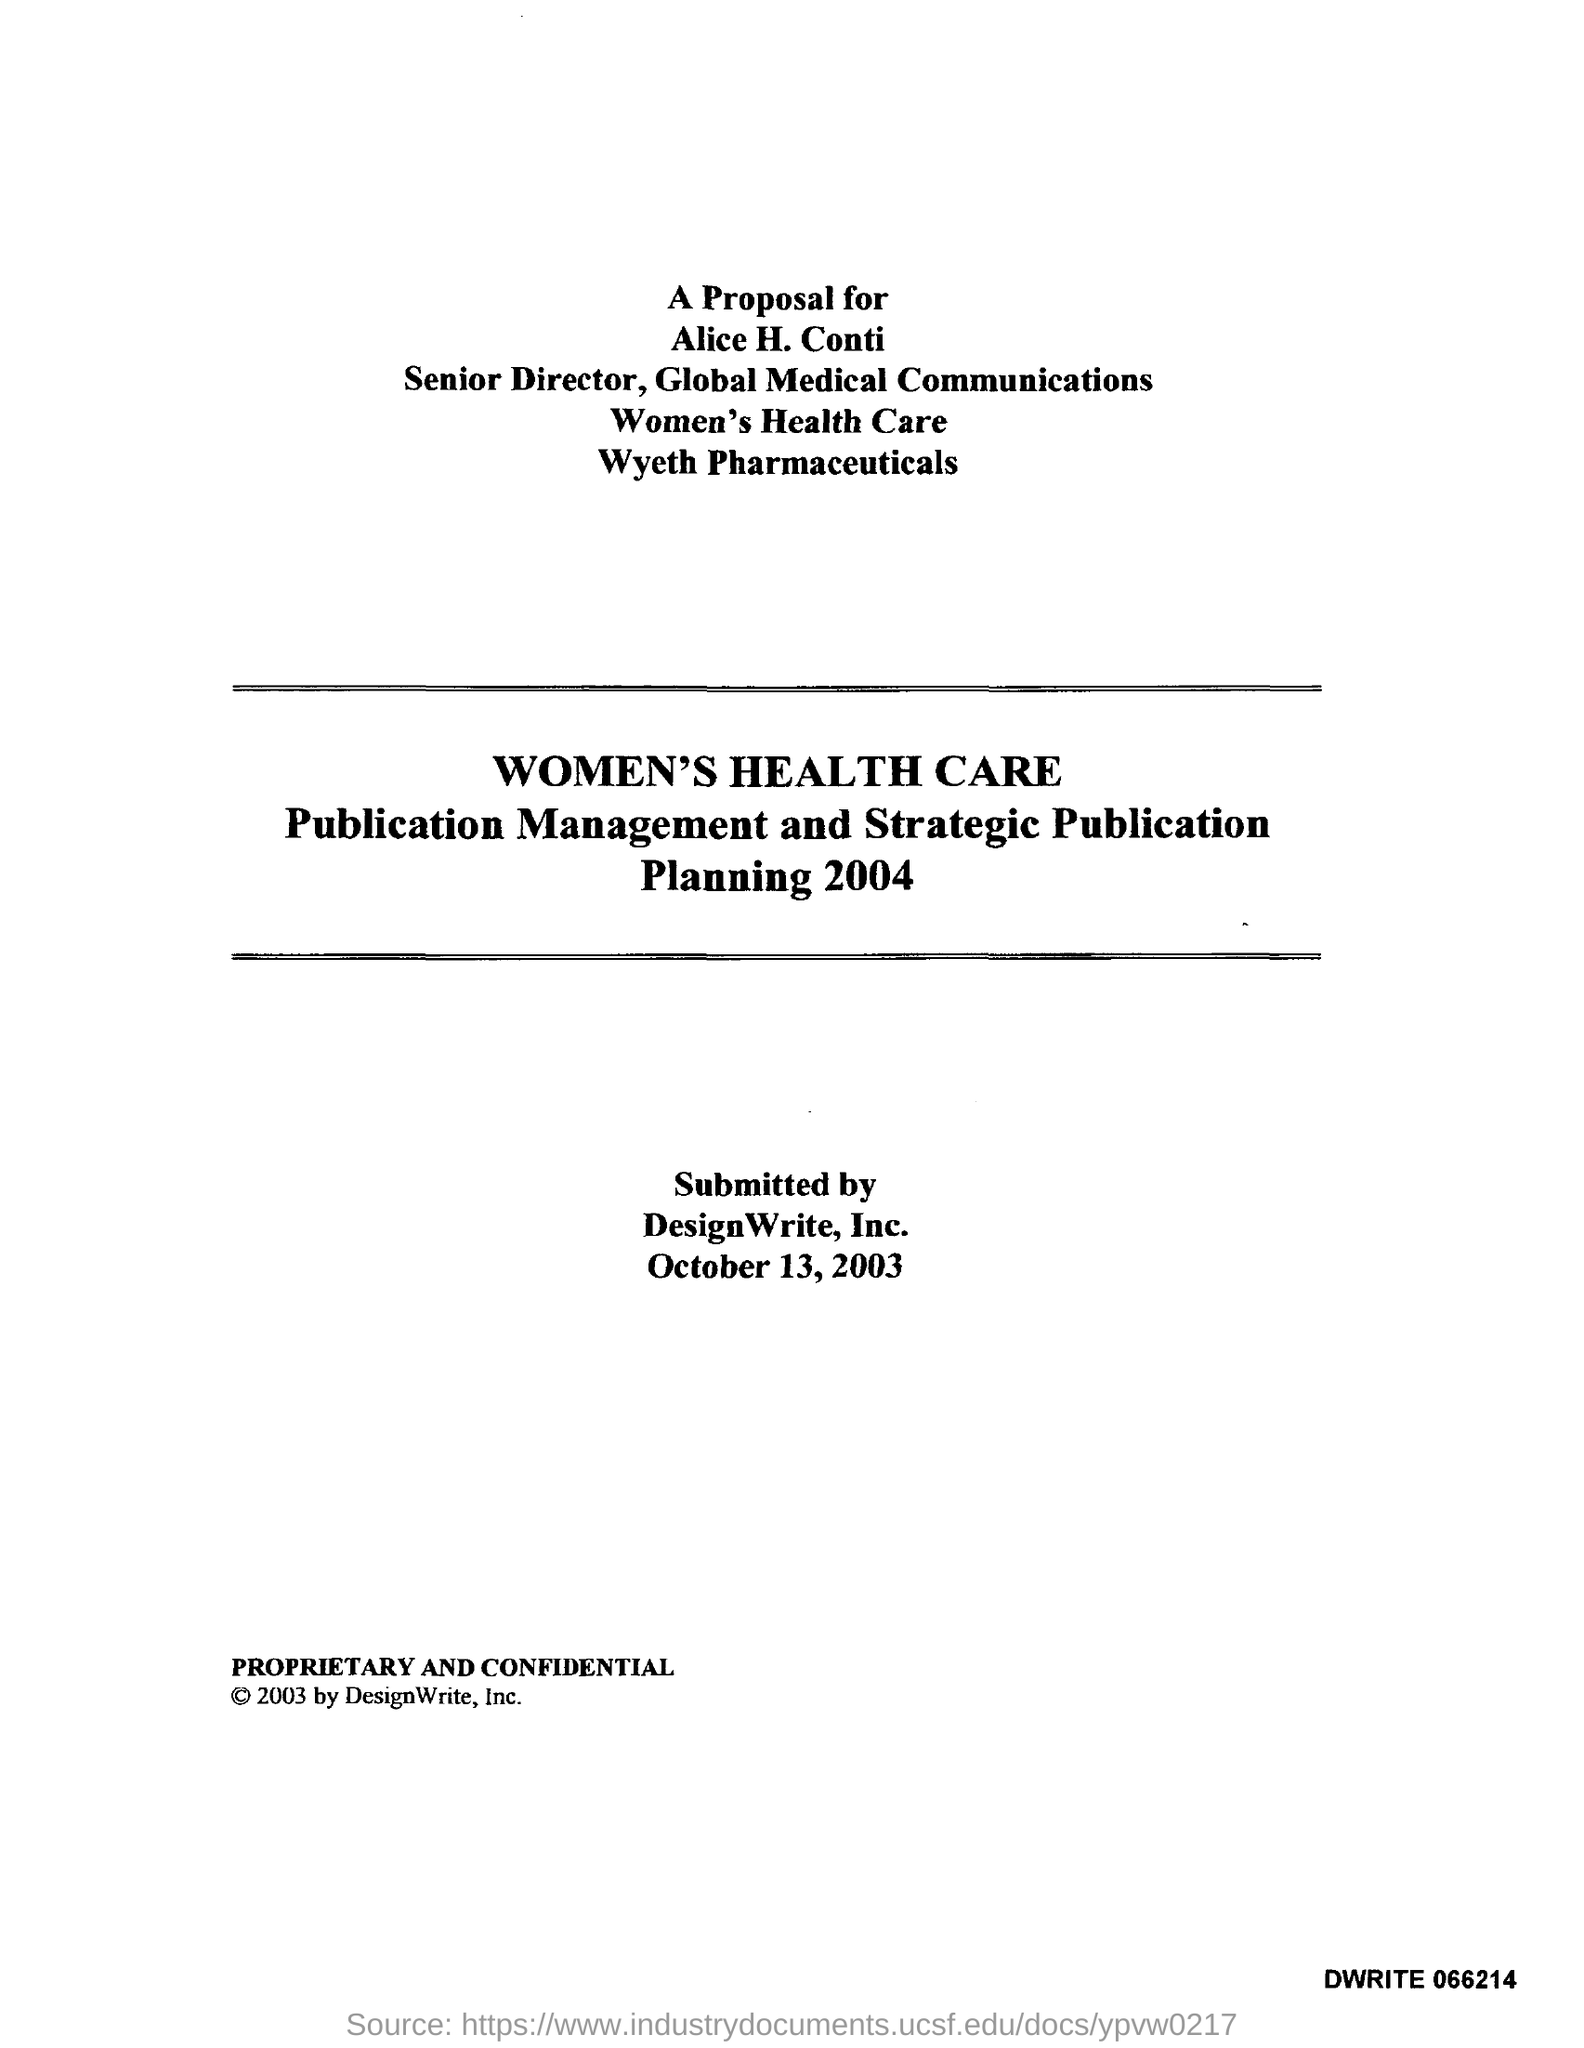Indicate a few pertinent items in this graphic. Alice H. Conti holds the designation of Senior Director. 